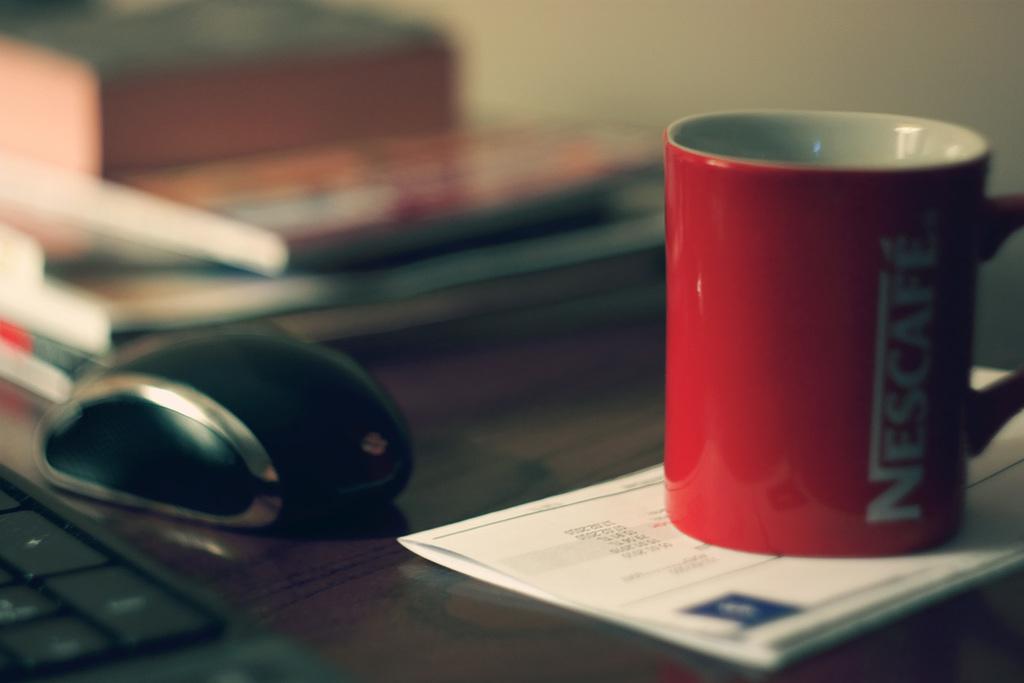What brand is on the mug?
Your response must be concise. Nescafe. 